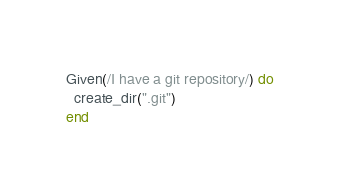Convert code to text. <code><loc_0><loc_0><loc_500><loc_500><_Ruby_>
Given(/I have a git repository/) do
  create_dir(".git")
end
</code> 